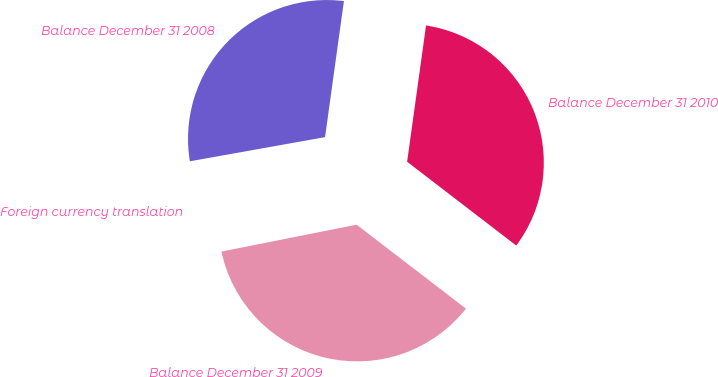Convert chart. <chart><loc_0><loc_0><loc_500><loc_500><pie_chart><fcel>Balance December 31 2008<fcel>Foreign currency translation<fcel>Balance December 31 2009<fcel>Balance December 31 2010<nl><fcel>30.01%<fcel>0.31%<fcel>36.45%<fcel>33.23%<nl></chart> 